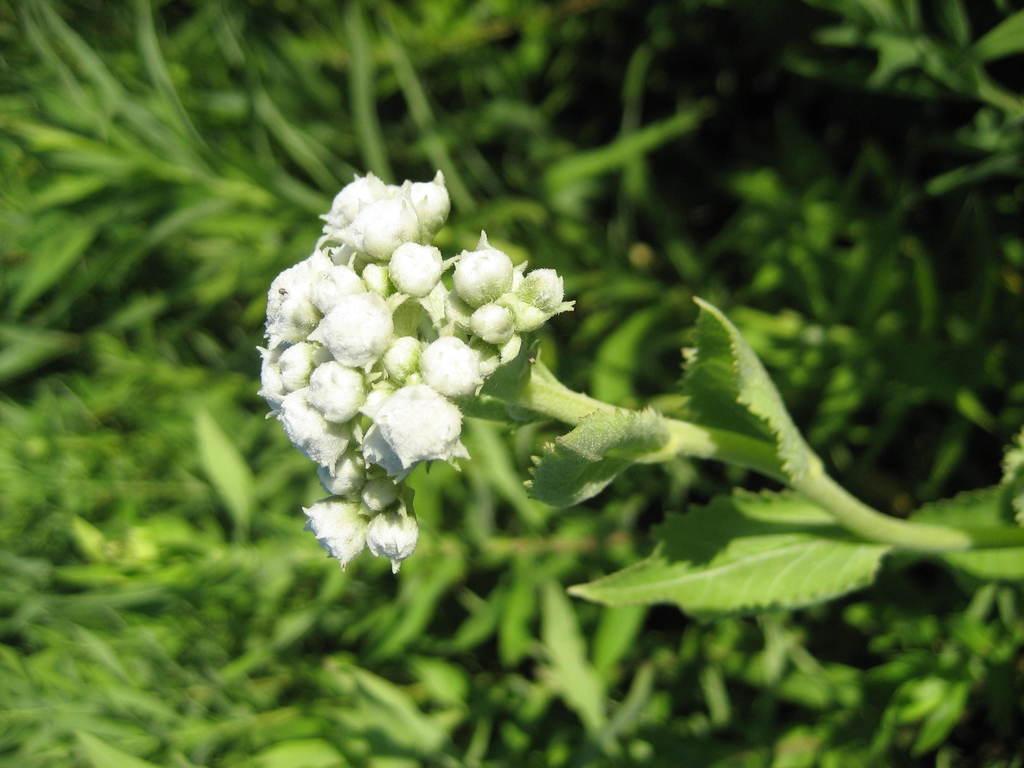Can you describe this image briefly? In this image there are flower buds and plants, in the background it is blurred. 